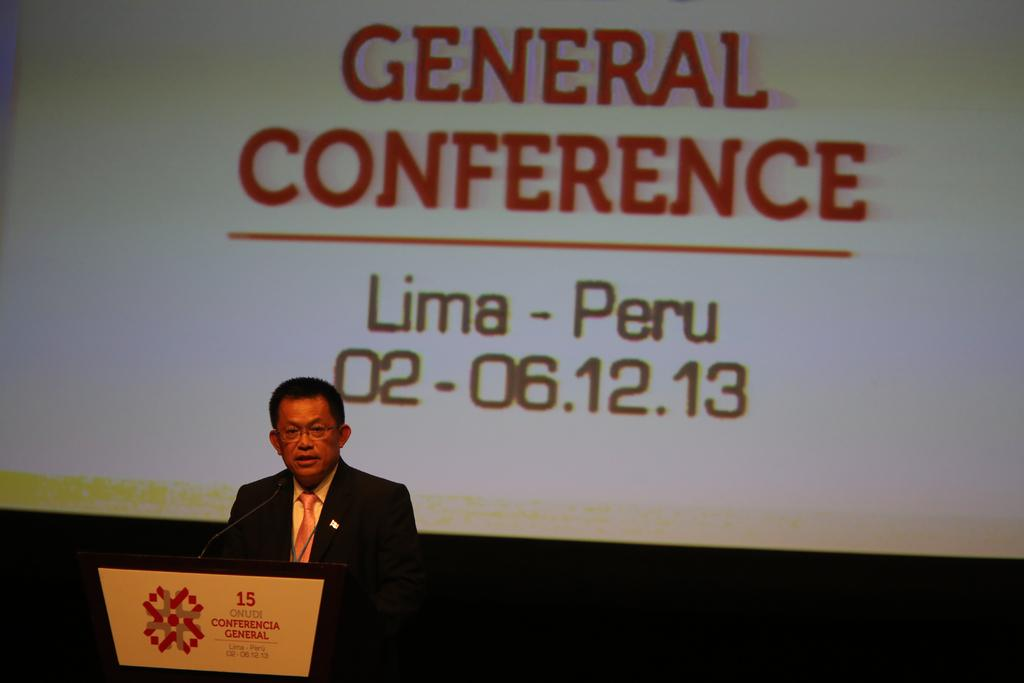What is the man in the image doing? The man is speaking in the image. What type of clothing is the man wearing? The man is wearing a coat, a tie, and a shirt. What is behind the man in the image? There is a projector screen behind the man. Can you see any mice running around on the projector screen in the image? There are no mice visible on the projector screen in the image. What type of feather is the man using to make his point while speaking? There is no feather present in the image; the man is simply speaking without any props or additional objects. 